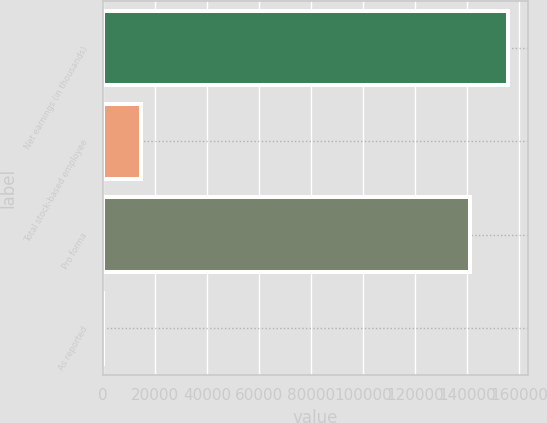<chart> <loc_0><loc_0><loc_500><loc_500><bar_chart><fcel>Net earnings (in thousands)<fcel>Total stock-based employee<fcel>Pro forma<fcel>As reported<nl><fcel>155635<fcel>14627.2<fcel>141010<fcel>1.81<nl></chart> 